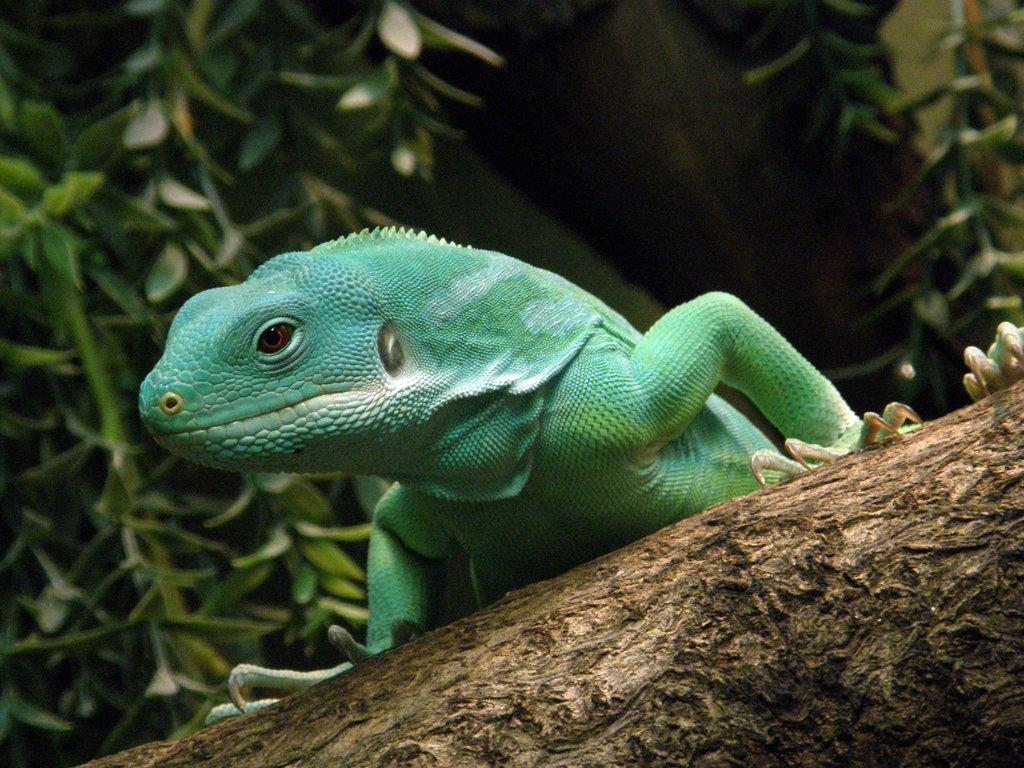What type of animal is in the image? There is a reptile in the image. What color is the reptile? The reptile is green in color. What can be seen in the background of the image? There are plants in the background of the image. What color are the plants? The plants are green in color. What type of action is the grandfather performing in the image? There is no grandfather present in the image, so no action can be attributed to him. 